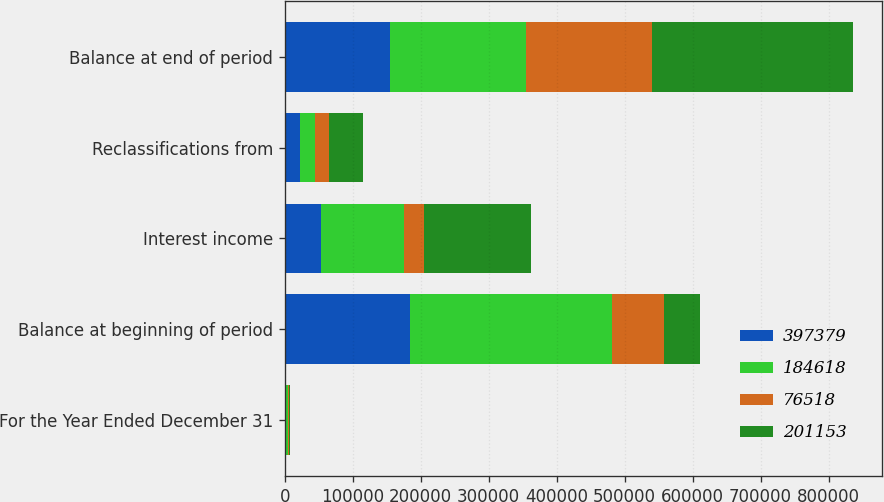Convert chart. <chart><loc_0><loc_0><loc_500><loc_500><stacked_bar_chart><ecel><fcel>For the Year Ended December 31<fcel>Balance at beginning of period<fcel>Interest income<fcel>Reclassifications from<fcel>Balance at end of period<nl><fcel>397379<fcel>2016<fcel>184618<fcel>52769<fcel>22384<fcel>154233<nl><fcel>184618<fcel>2016<fcel>296434<fcel>123044<fcel>22677<fcel>201153<nl><fcel>76518<fcel>2015<fcel>76518<fcel>28551<fcel>19400<fcel>184618<nl><fcel>201153<fcel>2015<fcel>52769<fcel>158260<fcel>49930<fcel>296434<nl></chart> 